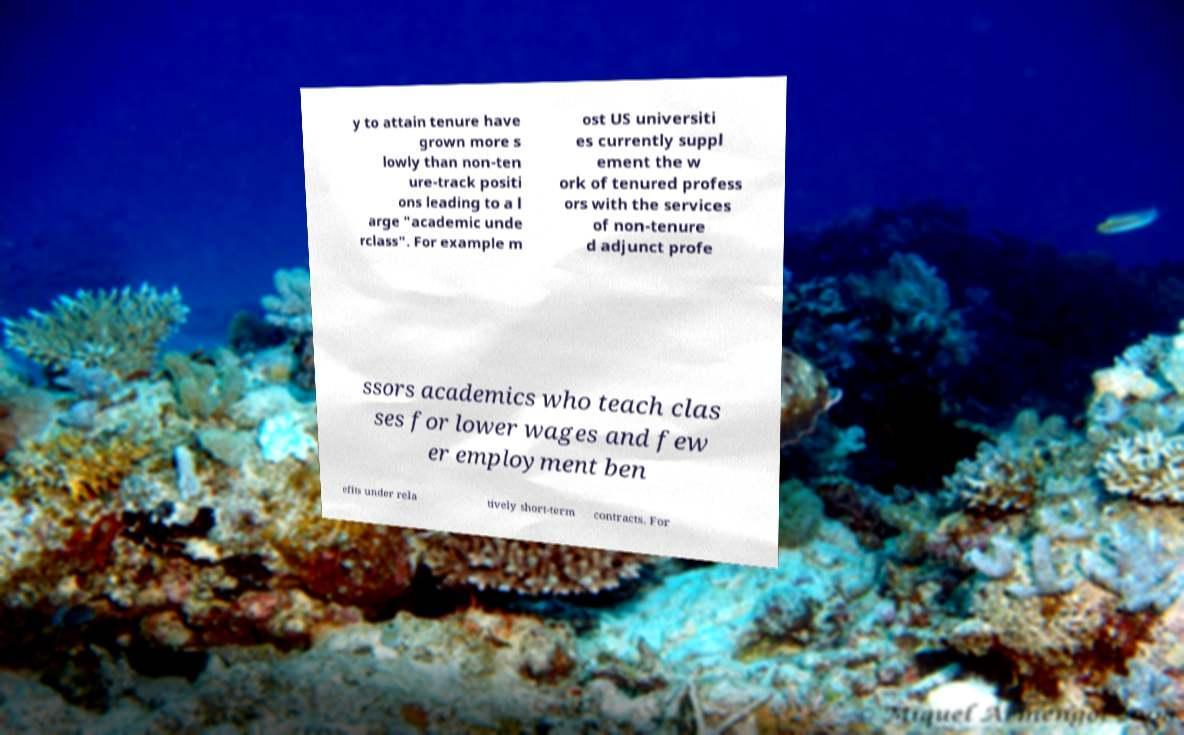Can you read and provide the text displayed in the image?This photo seems to have some interesting text. Can you extract and type it out for me? y to attain tenure have grown more s lowly than non-ten ure-track positi ons leading to a l arge "academic unde rclass". For example m ost US universiti es currently suppl ement the w ork of tenured profess ors with the services of non-tenure d adjunct profe ssors academics who teach clas ses for lower wages and few er employment ben efits under rela tively short-term contracts. For 